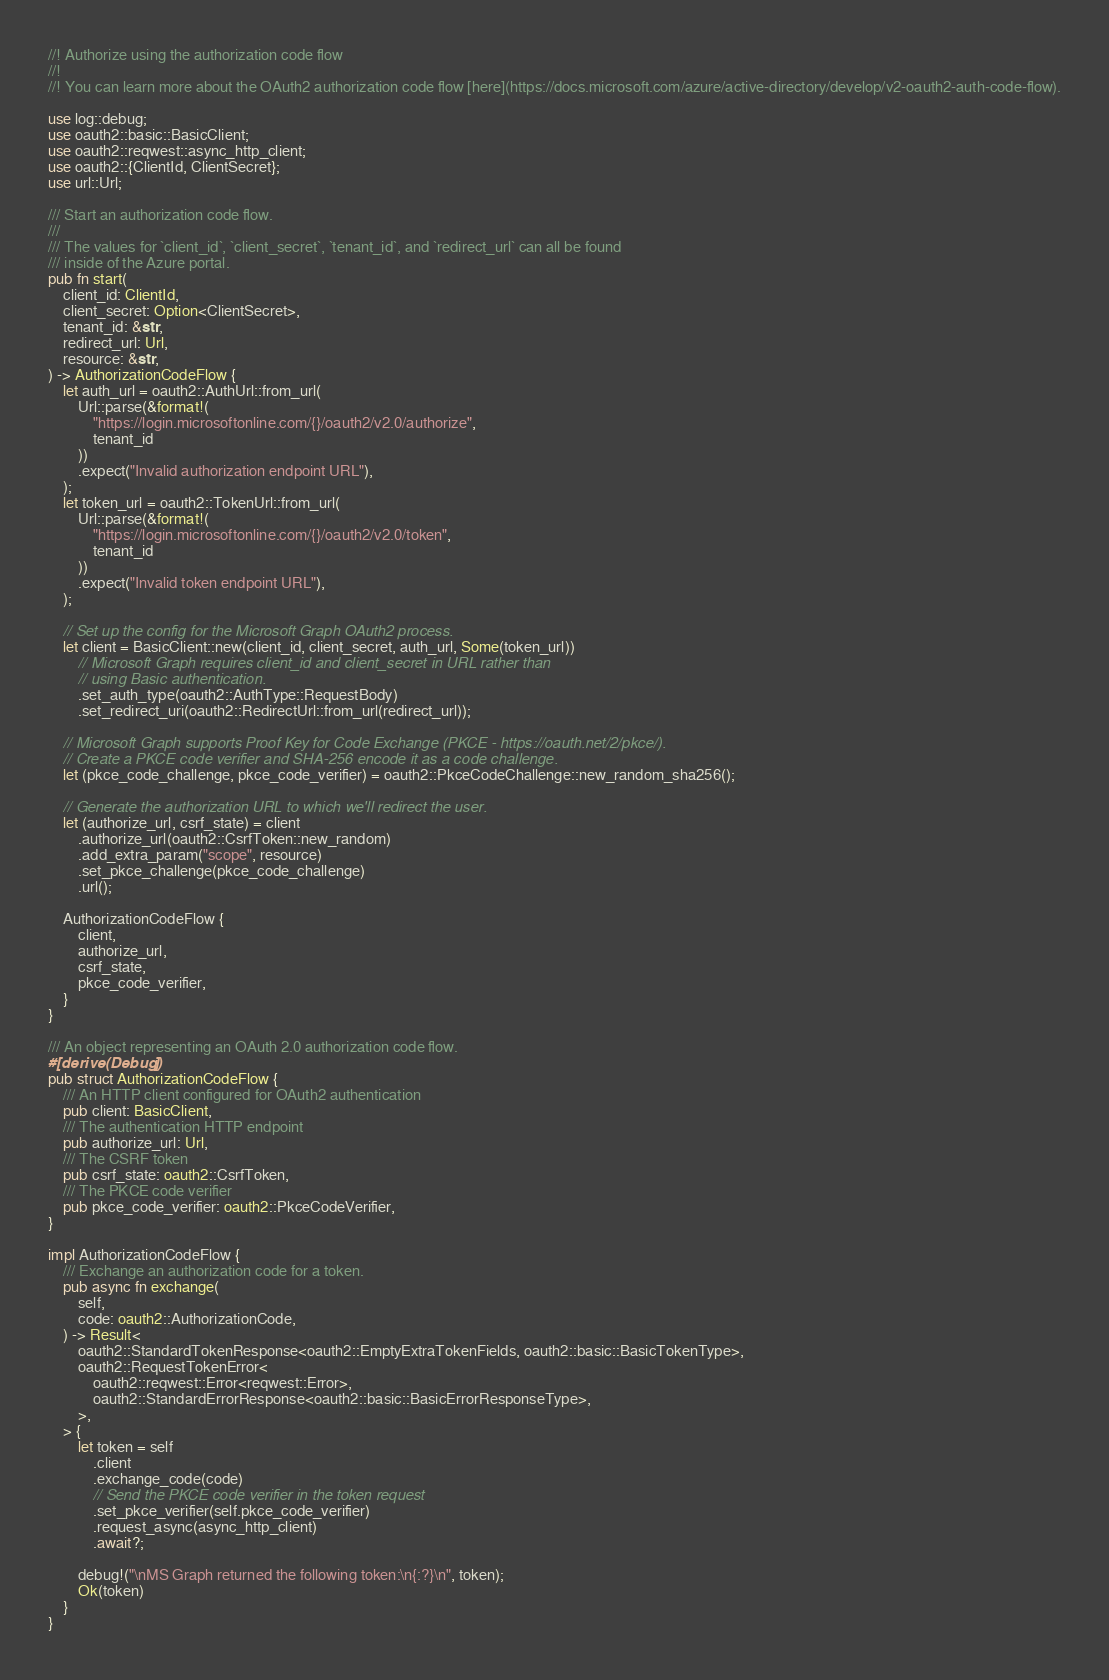Convert code to text. <code><loc_0><loc_0><loc_500><loc_500><_Rust_>//! Authorize using the authorization code flow
//!
//! You can learn more about the OAuth2 authorization code flow [here](https://docs.microsoft.com/azure/active-directory/develop/v2-oauth2-auth-code-flow).

use log::debug;
use oauth2::basic::BasicClient;
use oauth2::reqwest::async_http_client;
use oauth2::{ClientId, ClientSecret};
use url::Url;

/// Start an authorization code flow.
///
/// The values for `client_id`, `client_secret`, `tenant_id`, and `redirect_url` can all be found
/// inside of the Azure portal.
pub fn start(
    client_id: ClientId,
    client_secret: Option<ClientSecret>,
    tenant_id: &str,
    redirect_url: Url,
    resource: &str,
) -> AuthorizationCodeFlow {
    let auth_url = oauth2::AuthUrl::from_url(
        Url::parse(&format!(
            "https://login.microsoftonline.com/{}/oauth2/v2.0/authorize",
            tenant_id
        ))
        .expect("Invalid authorization endpoint URL"),
    );
    let token_url = oauth2::TokenUrl::from_url(
        Url::parse(&format!(
            "https://login.microsoftonline.com/{}/oauth2/v2.0/token",
            tenant_id
        ))
        .expect("Invalid token endpoint URL"),
    );

    // Set up the config for the Microsoft Graph OAuth2 process.
    let client = BasicClient::new(client_id, client_secret, auth_url, Some(token_url))
        // Microsoft Graph requires client_id and client_secret in URL rather than
        // using Basic authentication.
        .set_auth_type(oauth2::AuthType::RequestBody)
        .set_redirect_uri(oauth2::RedirectUrl::from_url(redirect_url));

    // Microsoft Graph supports Proof Key for Code Exchange (PKCE - https://oauth.net/2/pkce/).
    // Create a PKCE code verifier and SHA-256 encode it as a code challenge.
    let (pkce_code_challenge, pkce_code_verifier) = oauth2::PkceCodeChallenge::new_random_sha256();

    // Generate the authorization URL to which we'll redirect the user.
    let (authorize_url, csrf_state) = client
        .authorize_url(oauth2::CsrfToken::new_random)
        .add_extra_param("scope", resource)
        .set_pkce_challenge(pkce_code_challenge)
        .url();

    AuthorizationCodeFlow {
        client,
        authorize_url,
        csrf_state,
        pkce_code_verifier,
    }
}

/// An object representing an OAuth 2.0 authorization code flow.
#[derive(Debug)]
pub struct AuthorizationCodeFlow {
    /// An HTTP client configured for OAuth2 authentication
    pub client: BasicClient,
    /// The authentication HTTP endpoint
    pub authorize_url: Url,
    /// The CSRF token
    pub csrf_state: oauth2::CsrfToken,
    /// The PKCE code verifier
    pub pkce_code_verifier: oauth2::PkceCodeVerifier,
}

impl AuthorizationCodeFlow {
    /// Exchange an authorization code for a token.
    pub async fn exchange(
        self,
        code: oauth2::AuthorizationCode,
    ) -> Result<
        oauth2::StandardTokenResponse<oauth2::EmptyExtraTokenFields, oauth2::basic::BasicTokenType>,
        oauth2::RequestTokenError<
            oauth2::reqwest::Error<reqwest::Error>,
            oauth2::StandardErrorResponse<oauth2::basic::BasicErrorResponseType>,
        >,
    > {
        let token = self
            .client
            .exchange_code(code)
            // Send the PKCE code verifier in the token request
            .set_pkce_verifier(self.pkce_code_verifier)
            .request_async(async_http_client)
            .await?;

        debug!("\nMS Graph returned the following token:\n{:?}\n", token);
        Ok(token)
    }
}
</code> 